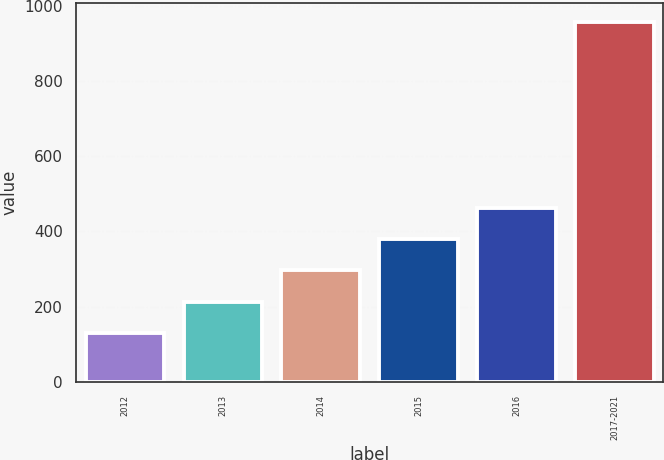<chart> <loc_0><loc_0><loc_500><loc_500><bar_chart><fcel>2012<fcel>2013<fcel>2014<fcel>2015<fcel>2016<fcel>2017-2021<nl><fcel>131<fcel>213.7<fcel>296.4<fcel>379.1<fcel>461.8<fcel>958<nl></chart> 